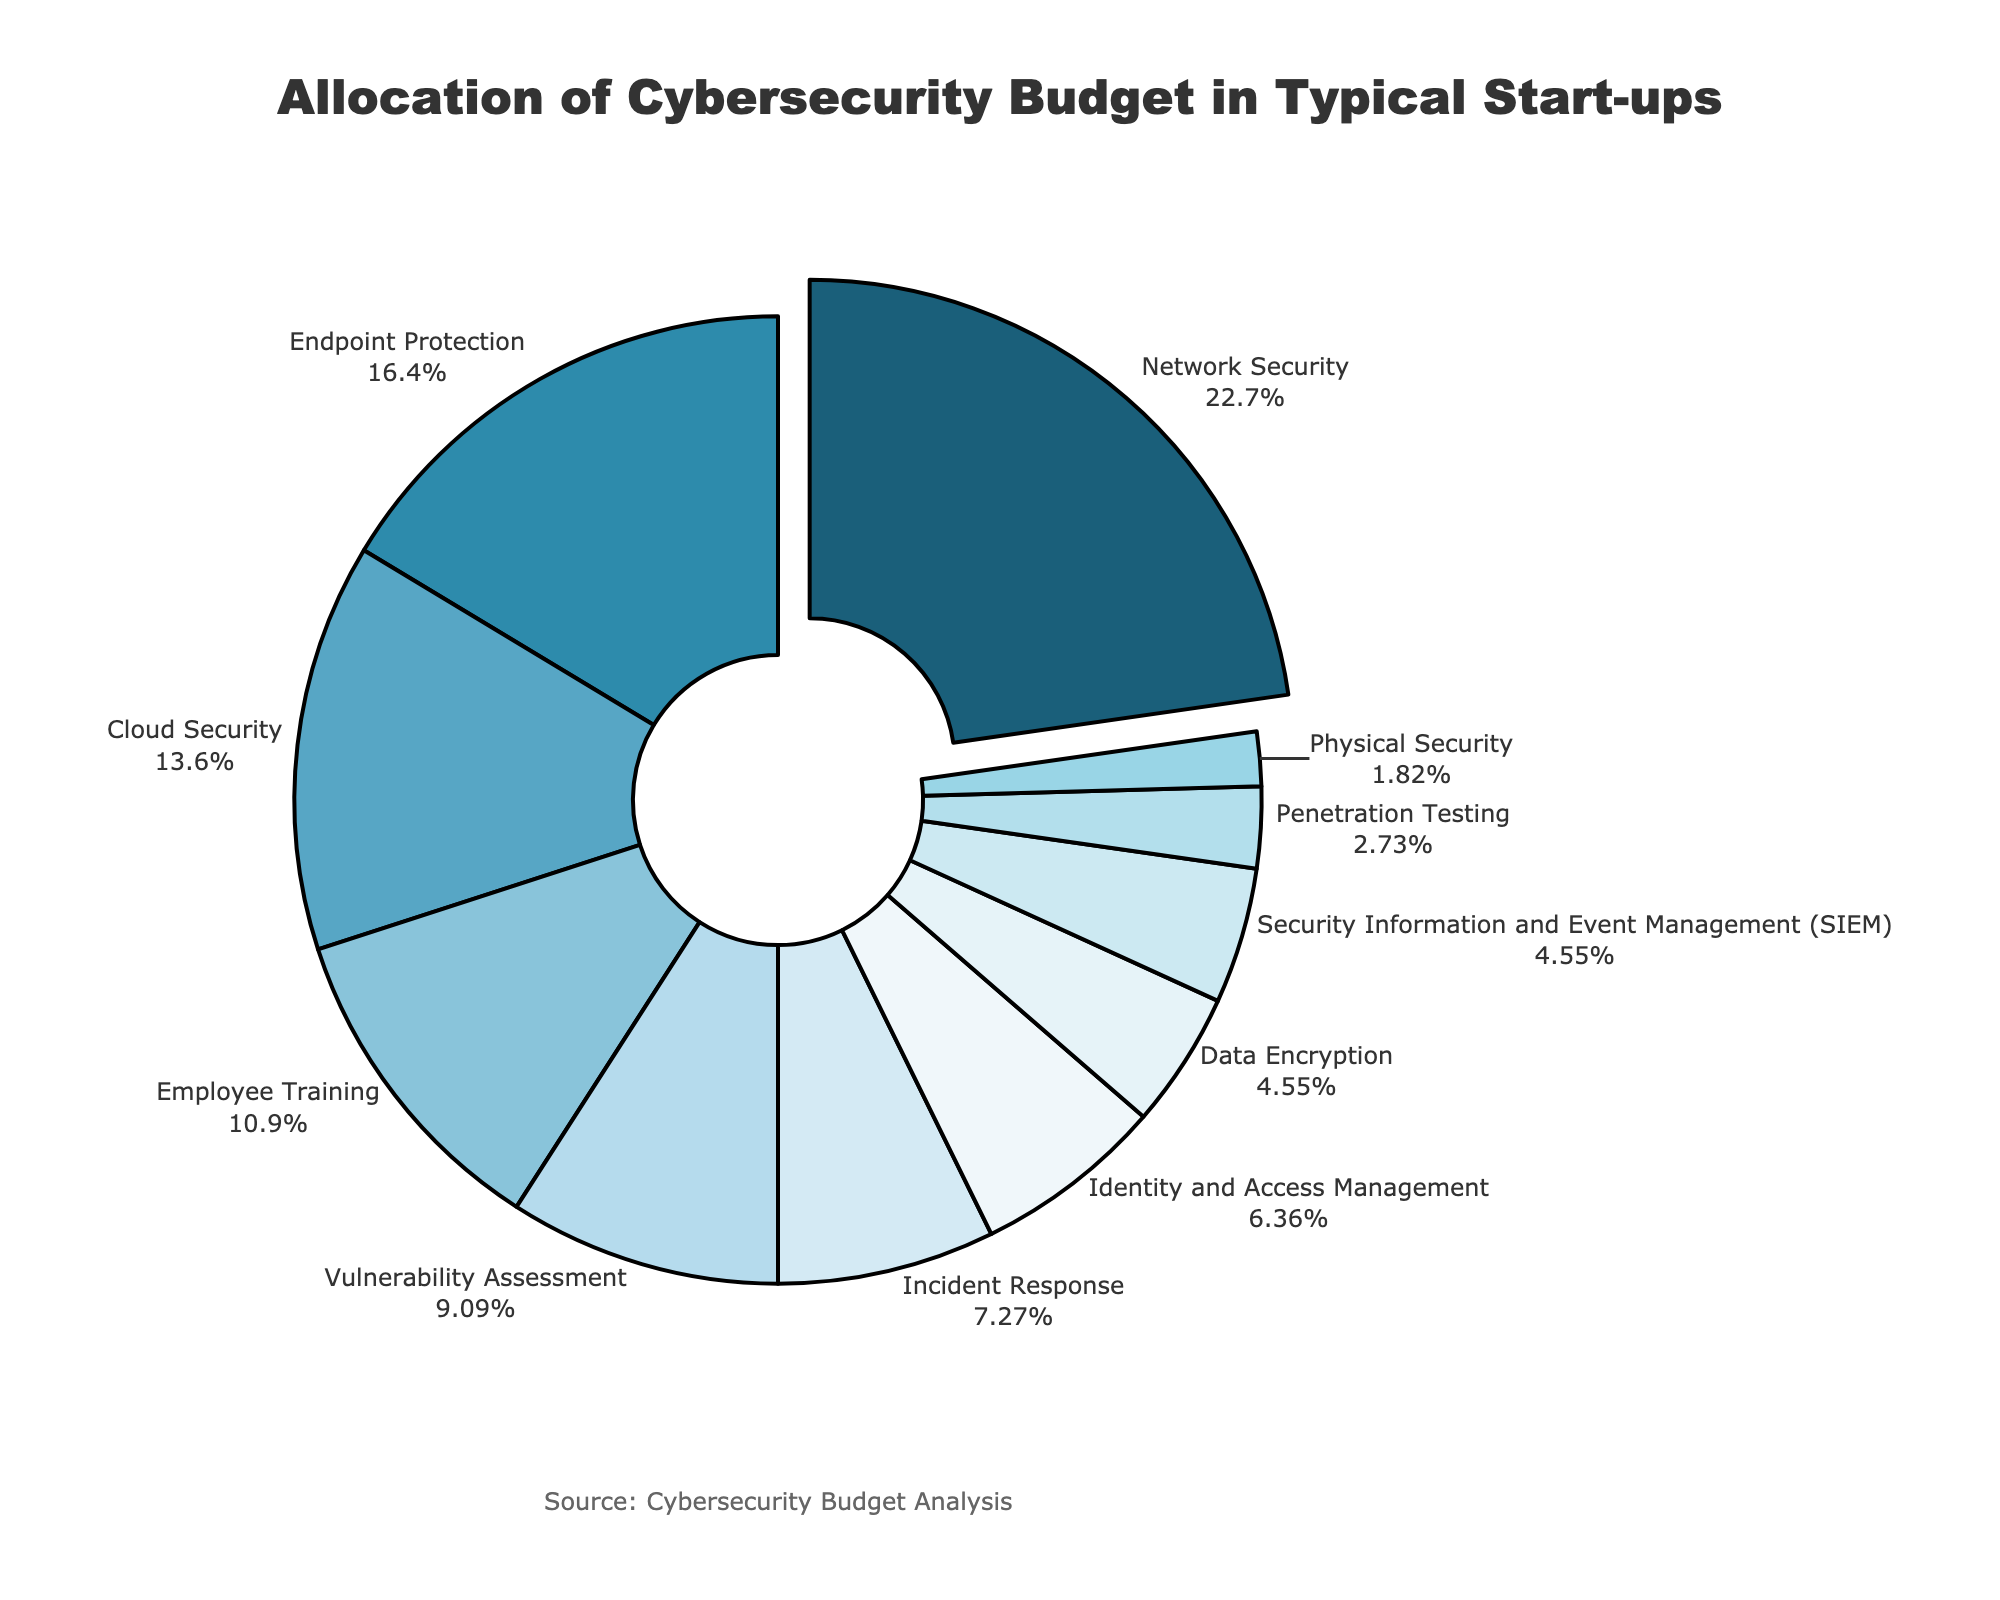What's the largest category in terms of budget allocation? By inspecting the pie chart, the largest slice represents Network Security. The 'Network Security' slice is visually the largest, taking up 25% of the chart.
Answer: Network Security Which category has the smallest budget allocation? The smallest slice, comprising only 2% of the chart, represents Physical Security.
Answer: Physical Security How much larger is the Network Security budget compared to Employee Training? Network Security is 25% while Employee Training is 12%. Subtracting these two percentages (25% - 12%) gives a difference of 13%.
Answer: 13% Which security measures have an equal budget allocation? Both 'Data Encryption' and 'Security Information and Event Management (SIEM)' slices represent the same percentage of the pie chart, each at 5%.
Answer: Data Encryption and SIEM What is the total combined budget allocation for Endpoint Protection, Cloud Security, and Employee Training? Endpoint Protection is 18%, Cloud Security is 15%, and Employee Training is 12%. Adding these percentages together (18 + 15 + 12) gives a total combined budget of 45%.
Answer: 45% How does the budget for Incident Response compare to Identity and Access Management? Incident Response takes up 8%, while Identity and Access Management takes up 7%. Incident Response has 1% more allocation compared to Identity and Access Management.
Answer: 1% What is the average budget allocation for the categories under 10%? The categories under 10% are: Vulnerability Assessment (10%), Incident Response (8%), Identity and Access Management (7%), Data Encryption (5%), Security Information and Event Management (SIEM) (5%), Penetration Testing (3%), and Physical Security (2%). Their total is 40% and there are 7 categories. So, the average is 40% / 7 ≈ 5.71%.
Answer: 5.71% What proportion of the budget is allocated to proactive security measures (e.g., Network Security, Endpoint Protection, and Vulnerability Assessment)? Network Security is 25%, Endpoint Protection is 18%, and Vulnerability Assessment is 10%. Adding these up (25 + 18 + 10) gives a total of 53%.
Answer: 53% Which category is represented by a blue shade closest to the center of the pie chart? The slice representing Endpoint Protection, which has a medium blue shade, is closest to the center and it stands for 18% of the budget.
Answer: Endpoint Protection 